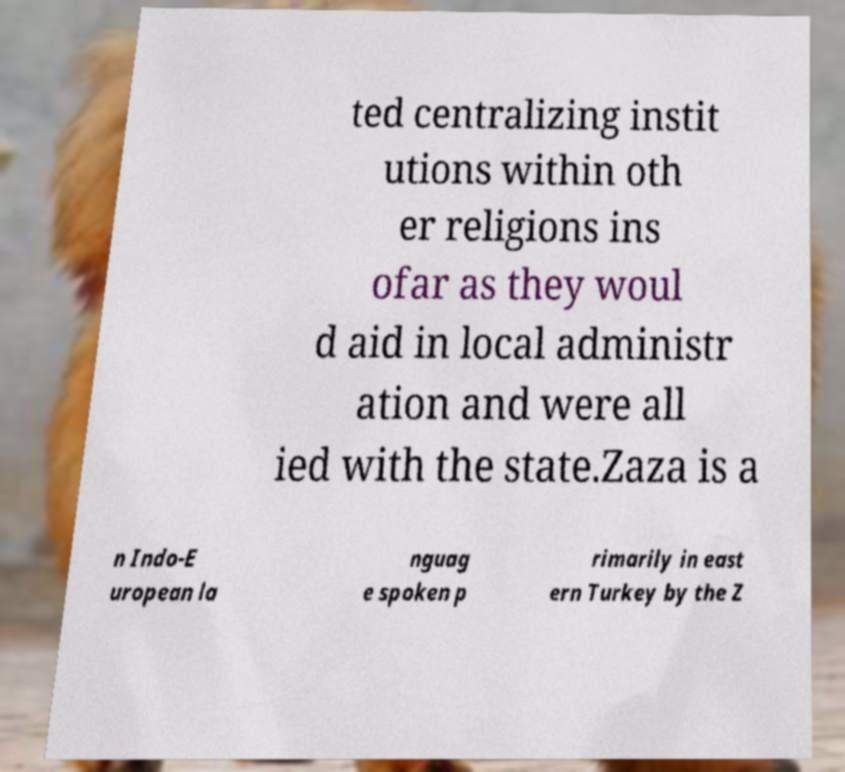Can you accurately transcribe the text from the provided image for me? ted centralizing instit utions within oth er religions ins ofar as they woul d aid in local administr ation and were all ied with the state.Zaza is a n Indo-E uropean la nguag e spoken p rimarily in east ern Turkey by the Z 